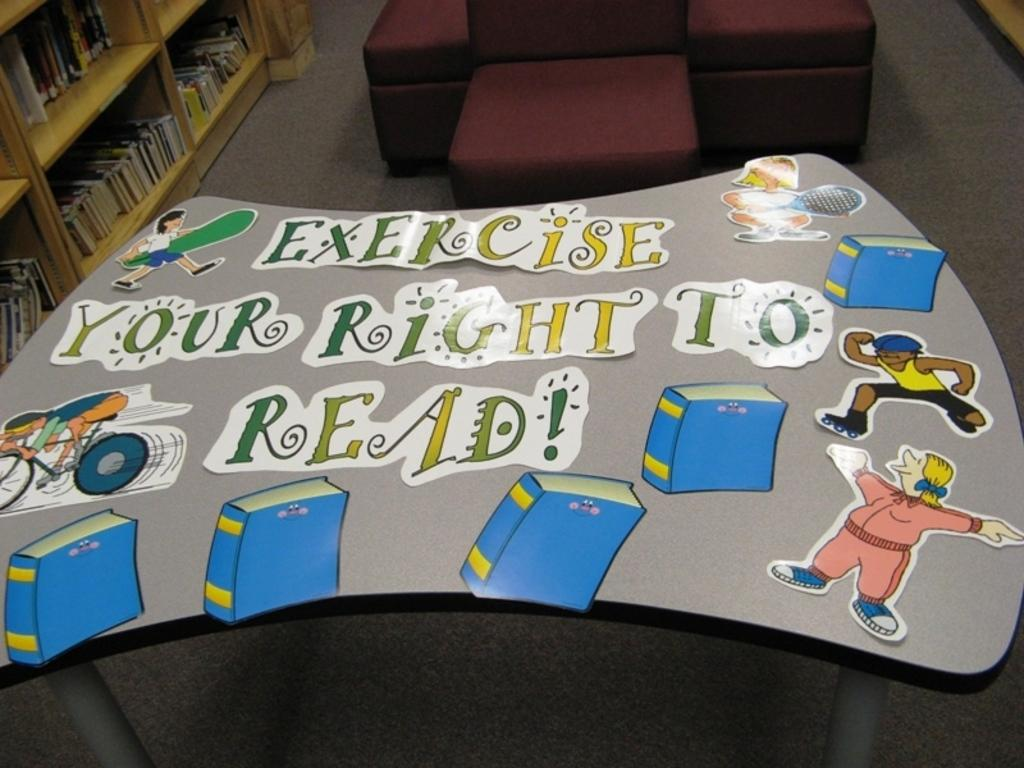<image>
Share a concise interpretation of the image provided. A table displays the message, "Exercise your right to read." 